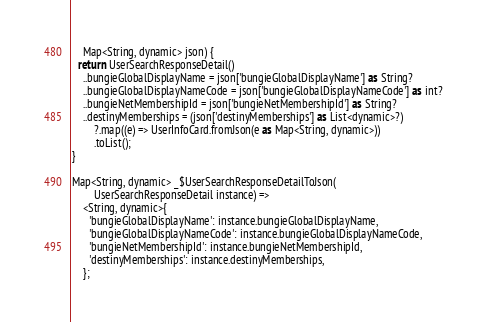<code> <loc_0><loc_0><loc_500><loc_500><_Dart_>    Map<String, dynamic> json) {
  return UserSearchResponseDetail()
    ..bungieGlobalDisplayName = json['bungieGlobalDisplayName'] as String?
    ..bungieGlobalDisplayNameCode = json['bungieGlobalDisplayNameCode'] as int?
    ..bungieNetMembershipId = json['bungieNetMembershipId'] as String?
    ..destinyMemberships = (json['destinyMemberships'] as List<dynamic>?)
        ?.map((e) => UserInfoCard.fromJson(e as Map<String, dynamic>))
        .toList();
}

Map<String, dynamic> _$UserSearchResponseDetailToJson(
        UserSearchResponseDetail instance) =>
    <String, dynamic>{
      'bungieGlobalDisplayName': instance.bungieGlobalDisplayName,
      'bungieGlobalDisplayNameCode': instance.bungieGlobalDisplayNameCode,
      'bungieNetMembershipId': instance.bungieNetMembershipId,
      'destinyMemberships': instance.destinyMemberships,
    };
</code> 